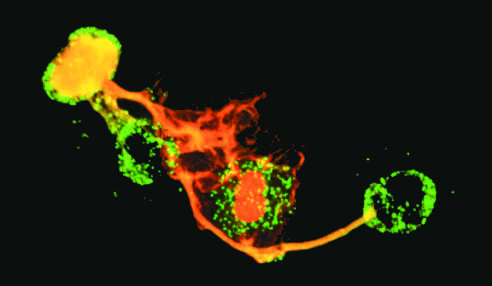two have lost whose nuclei?
Answer the question using a single word or phrase. Their 